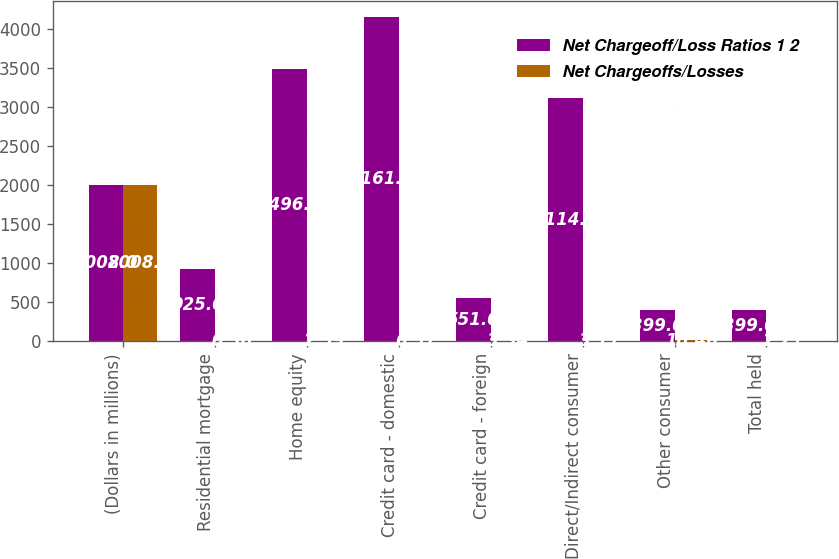Convert chart. <chart><loc_0><loc_0><loc_500><loc_500><stacked_bar_chart><ecel><fcel>(Dollars in millions)<fcel>Residential mortgage<fcel>Home equity<fcel>Credit card - domestic<fcel>Credit card - foreign<fcel>Direct/Indirect consumer<fcel>Other consumer<fcel>Total held<nl><fcel>Net Chargeoff/Loss Ratios 1 2<fcel>2008<fcel>925<fcel>3496<fcel>4161<fcel>551<fcel>3114<fcel>399<fcel>399<nl><fcel>Net Chargeoffs/Losses<fcel>2008<fcel>0.36<fcel>2.59<fcel>6.57<fcel>3.34<fcel>3.77<fcel>10.46<fcel>2.21<nl></chart> 